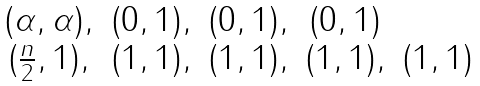Convert formula to latex. <formula><loc_0><loc_0><loc_500><loc_500>\begin{matrix} ( \alpha , \alpha ) , & ( 0 , 1 ) , & ( 0 , 1 ) , & ( 0 , 1 ) & \\ ( \frac { n } 2 , 1 ) , & ( 1 , 1 ) , & ( 1 , 1 ) , & ( 1 , 1 ) , & ( 1 , 1 ) \end{matrix}</formula> 